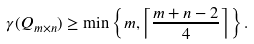Convert formula to latex. <formula><loc_0><loc_0><loc_500><loc_500>\gamma ( Q _ { m \times n } ) \geq \min \left \{ m , \left \lceil \frac { m + n - 2 } { 4 } \right \rceil \right \} .</formula> 